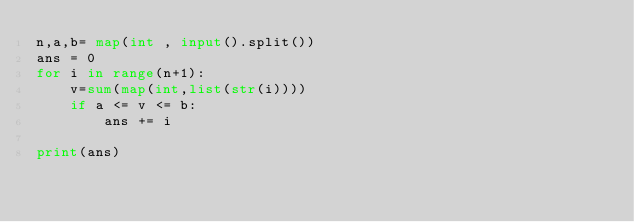Convert code to text. <code><loc_0><loc_0><loc_500><loc_500><_Python_>n,a,b= map(int , input().split())
ans = 0
for i in range(n+1):
	v=sum(map(int,list(str(i))))
	if a <= v <= b:
		ans += i

print(ans) </code> 